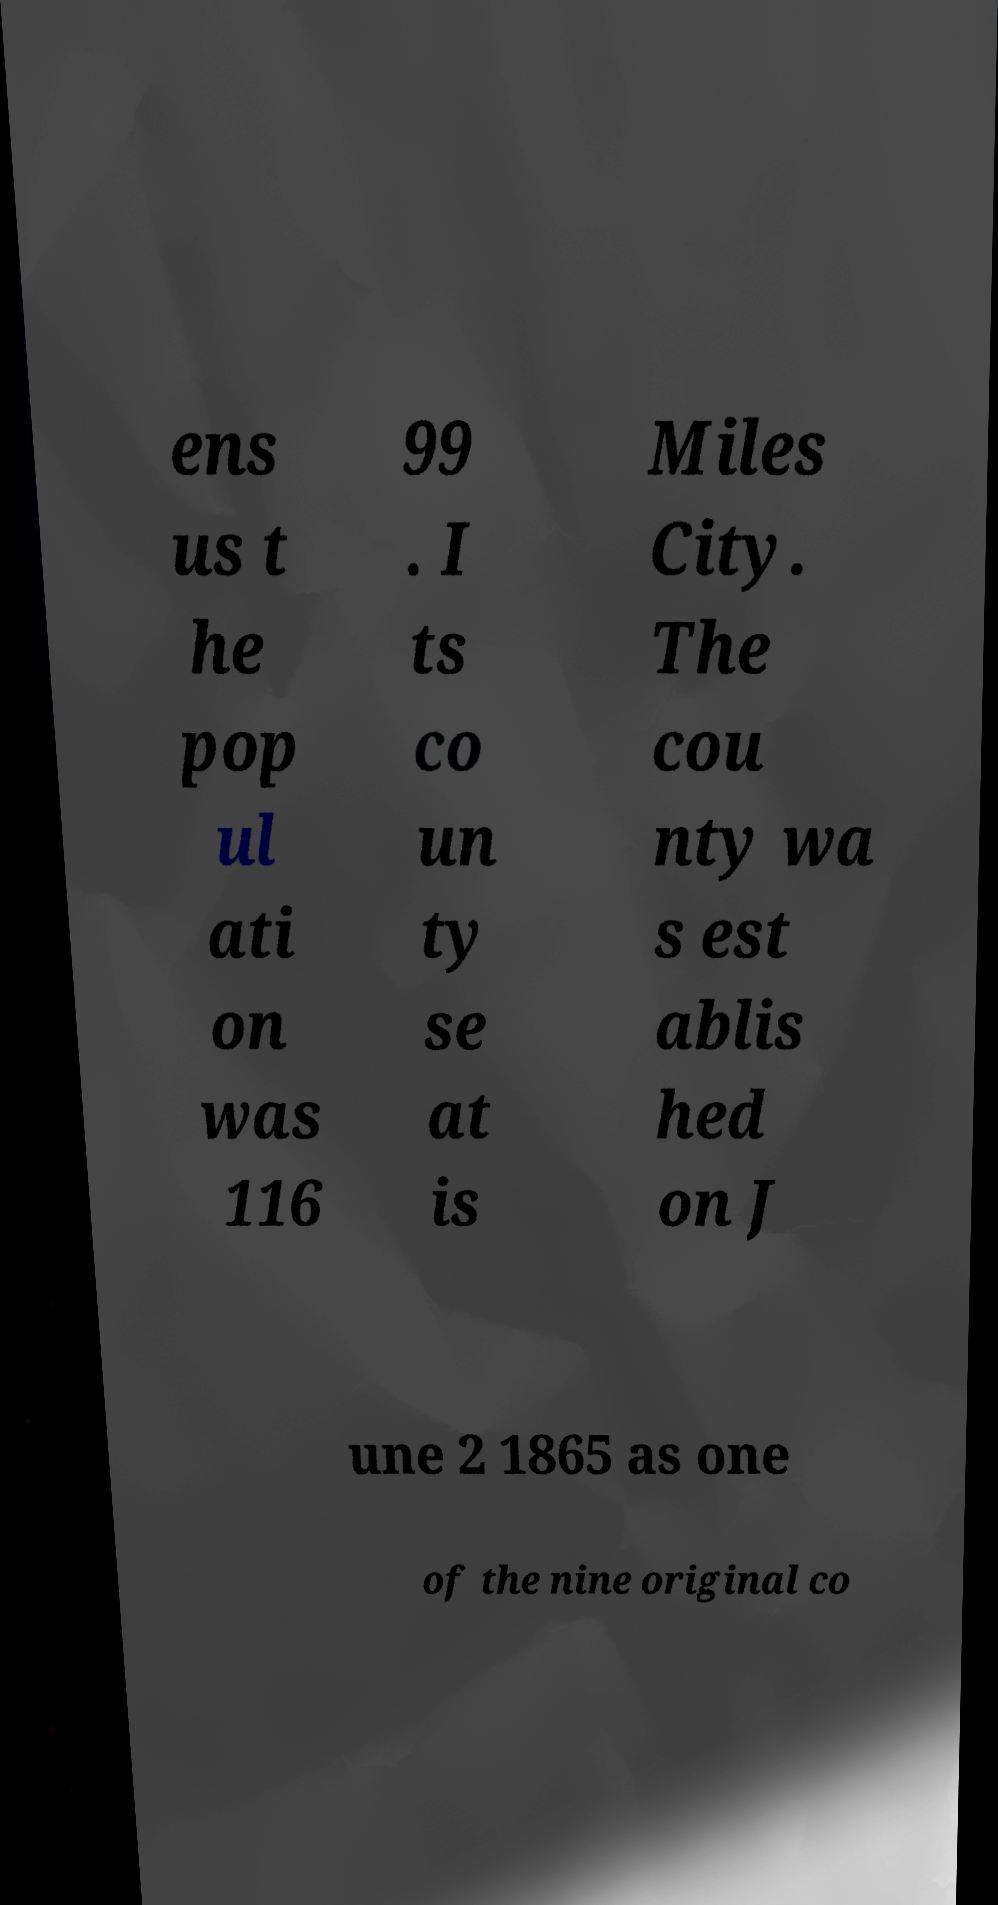Could you assist in decoding the text presented in this image and type it out clearly? ens us t he pop ul ati on was 116 99 . I ts co un ty se at is Miles City. The cou nty wa s est ablis hed on J une 2 1865 as one of the nine original co 